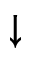Convert formula to latex. <formula><loc_0><loc_0><loc_500><loc_500>\downarrow</formula> 